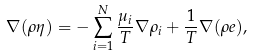Convert formula to latex. <formula><loc_0><loc_0><loc_500><loc_500>\nabla ( \rho \eta ) & = - \sum _ { i = 1 } ^ { N } \frac { \mu _ { i } } { T } \nabla \rho _ { i } + \frac { 1 } { T } \nabla ( \rho e ) ,</formula> 